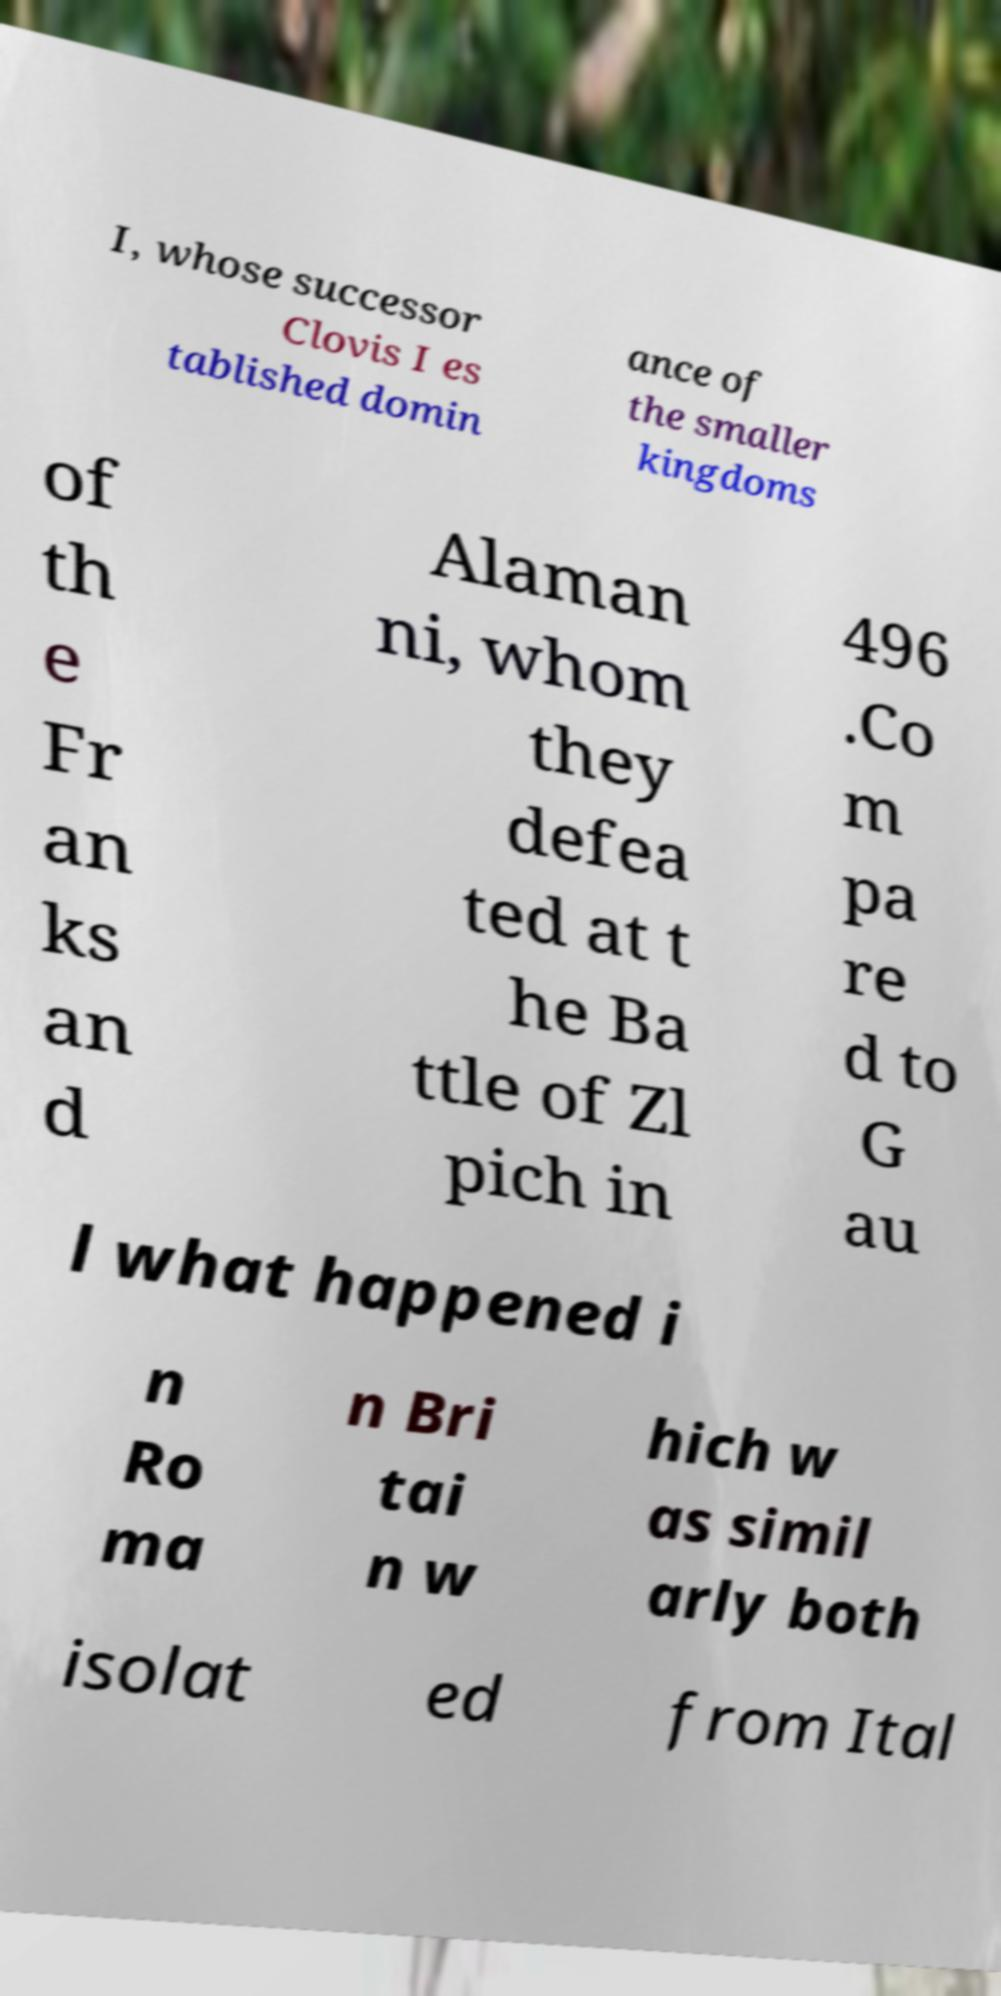Could you extract and type out the text from this image? I, whose successor Clovis I es tablished domin ance of the smaller kingdoms of th e Fr an ks an d Alaman ni, whom they defea ted at t he Ba ttle of Zl pich in 496 .Co m pa re d to G au l what happened i n Ro ma n Bri tai n w hich w as simil arly both isolat ed from Ital 